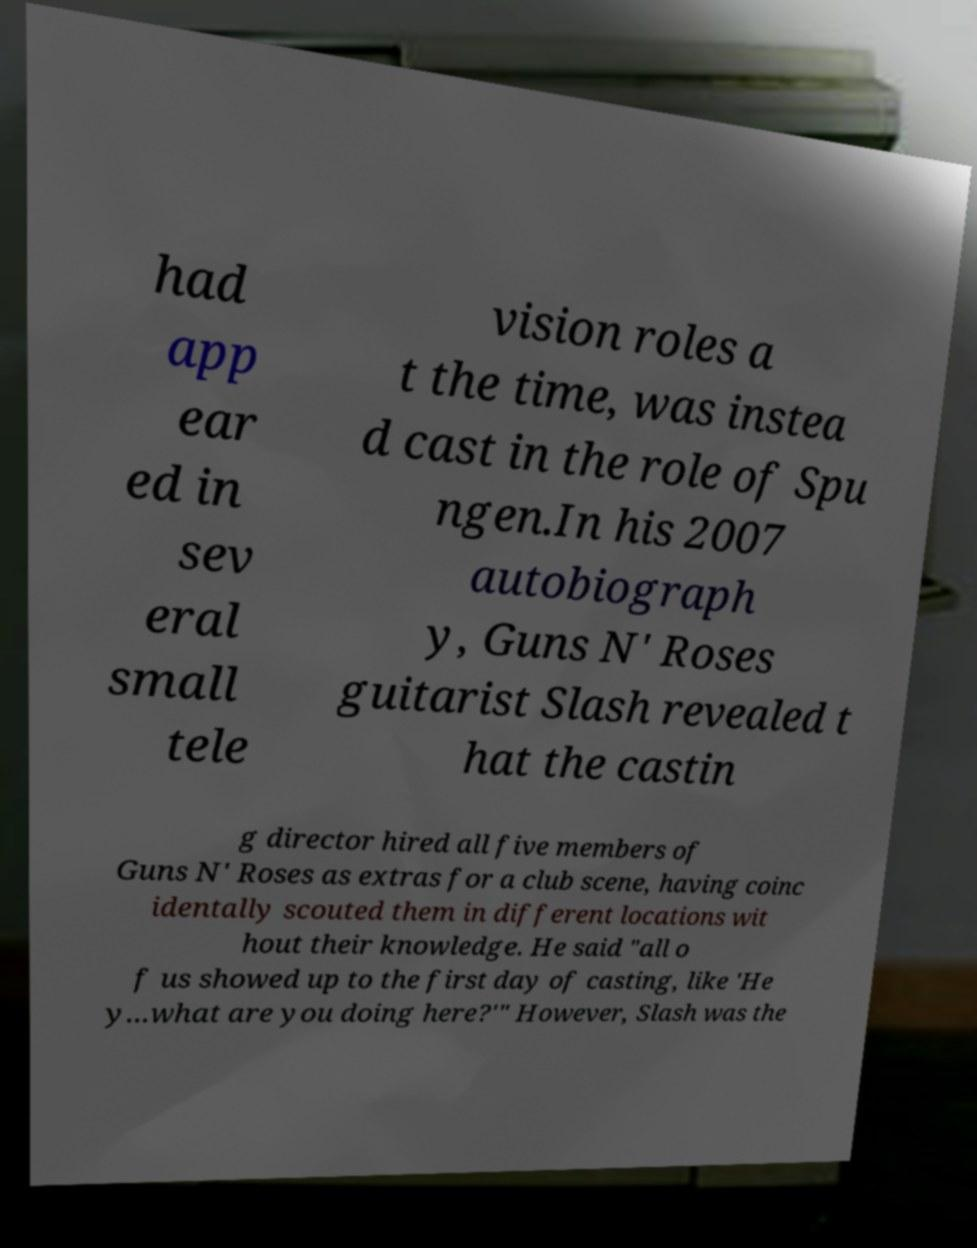Could you assist in decoding the text presented in this image and type it out clearly? had app ear ed in sev eral small tele vision roles a t the time, was instea d cast in the role of Spu ngen.In his 2007 autobiograph y, Guns N' Roses guitarist Slash revealed t hat the castin g director hired all five members of Guns N' Roses as extras for a club scene, having coinc identally scouted them in different locations wit hout their knowledge. He said "all o f us showed up to the first day of casting, like 'He y...what are you doing here?'" However, Slash was the 